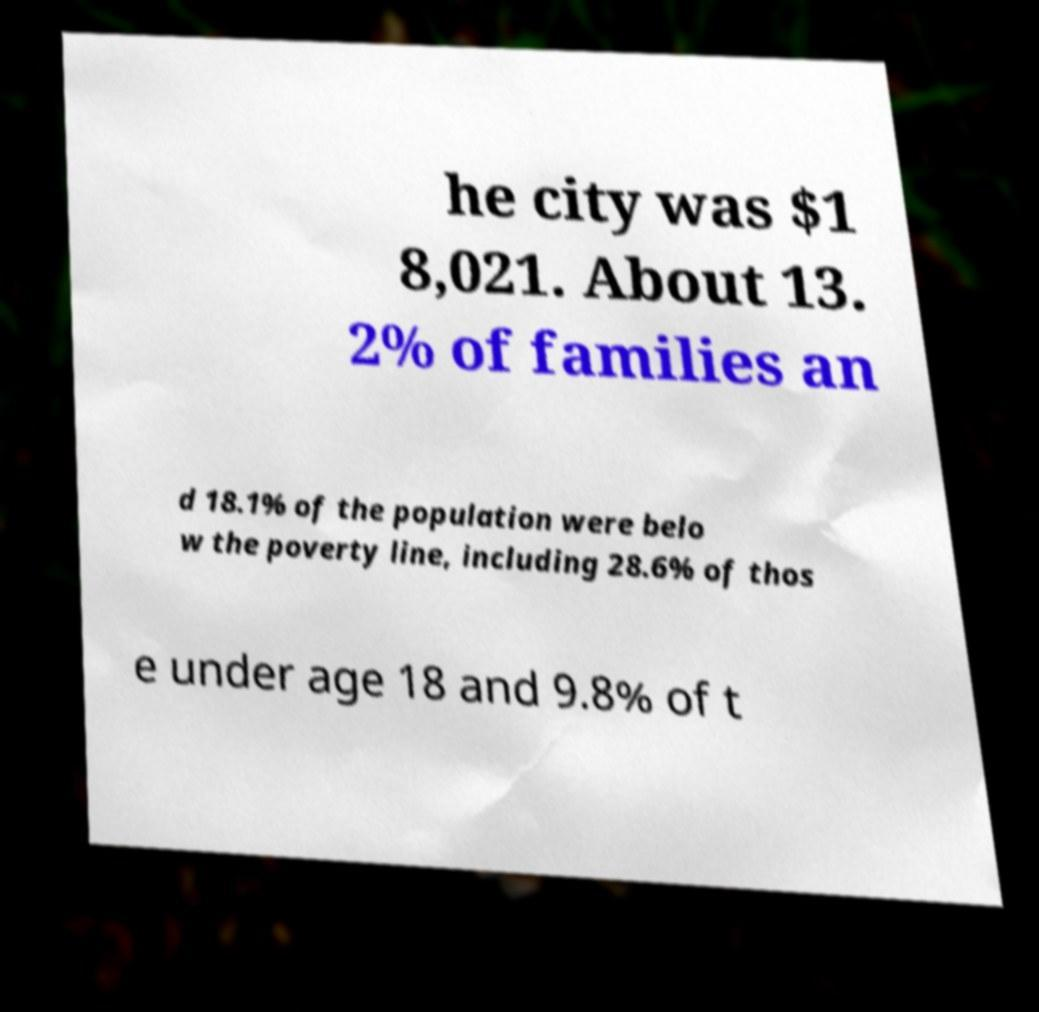I need the written content from this picture converted into text. Can you do that? he city was $1 8,021. About 13. 2% of families an d 18.1% of the population were belo w the poverty line, including 28.6% of thos e under age 18 and 9.8% of t 